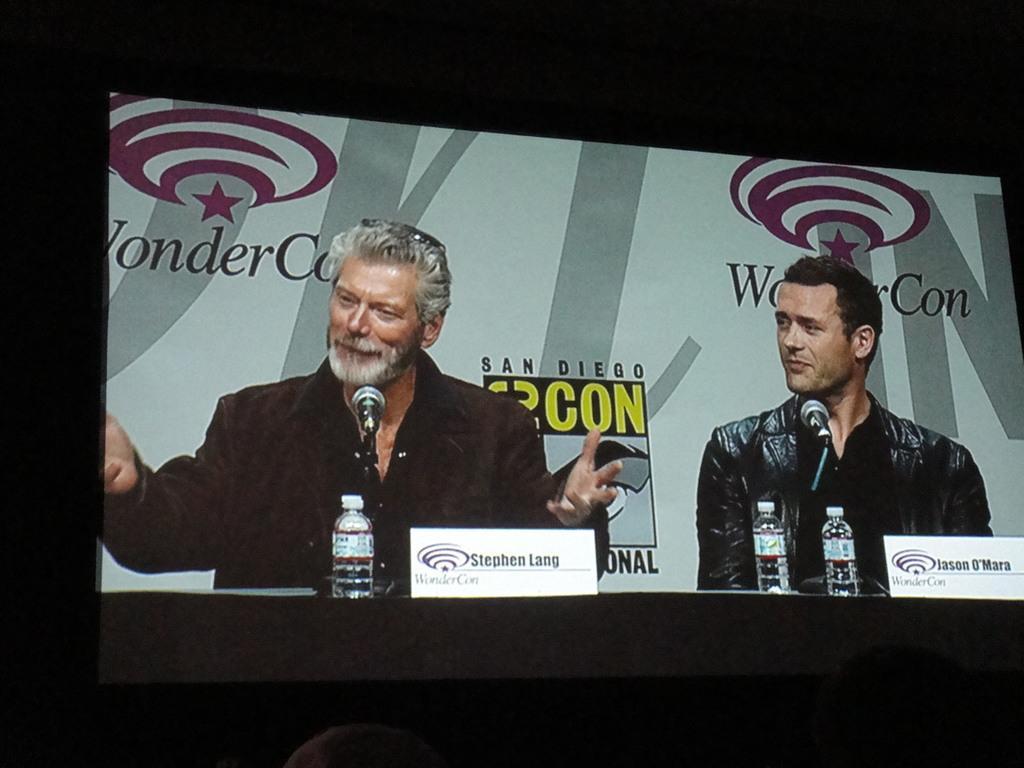Please provide a concise description of this image. There is a screen and in the screen there are two men sitting and behind the men there is a banner, in front of the screen there are two people. 